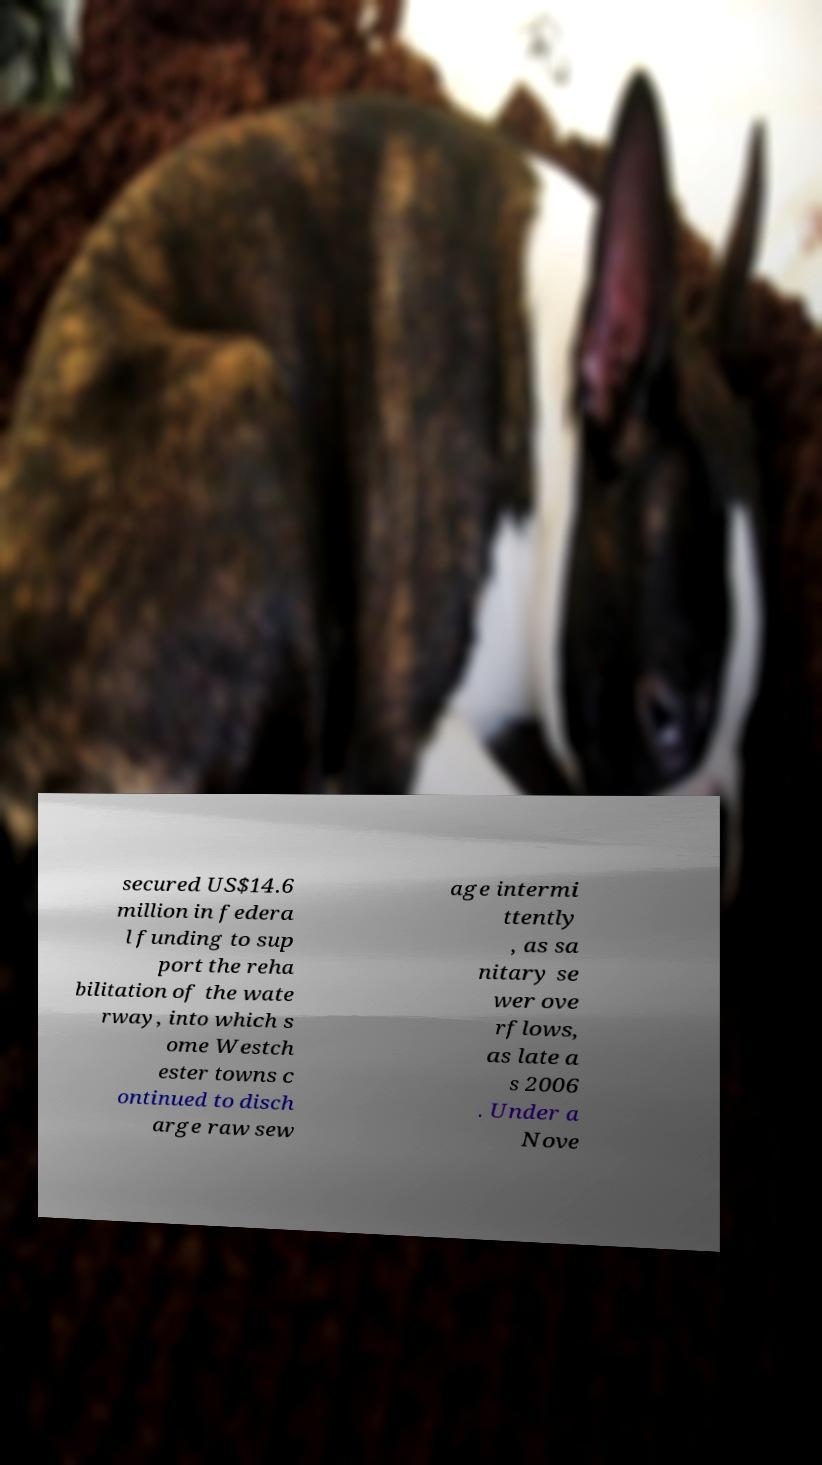Can you read and provide the text displayed in the image?This photo seems to have some interesting text. Can you extract and type it out for me? secured US$14.6 million in federa l funding to sup port the reha bilitation of the wate rway, into which s ome Westch ester towns c ontinued to disch arge raw sew age intermi ttently , as sa nitary se wer ove rflows, as late a s 2006 . Under a Nove 